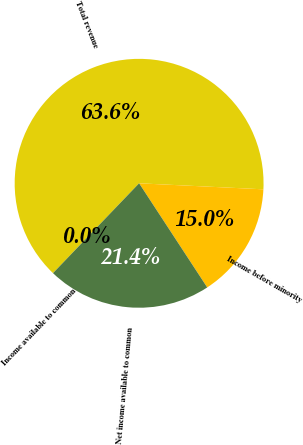<chart> <loc_0><loc_0><loc_500><loc_500><pie_chart><fcel>Total revenue<fcel>Income before minority<fcel>Net income available to common<fcel>Income available to common<nl><fcel>63.61%<fcel>15.01%<fcel>21.38%<fcel>0.0%<nl></chart> 